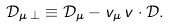Convert formula to latex. <formula><loc_0><loc_0><loc_500><loc_500>\mathcal { D } _ { \mu \, \perp } \equiv \mathcal { D } _ { \mu } - v _ { \mu } \, v \cdot \mathcal { D } .</formula> 